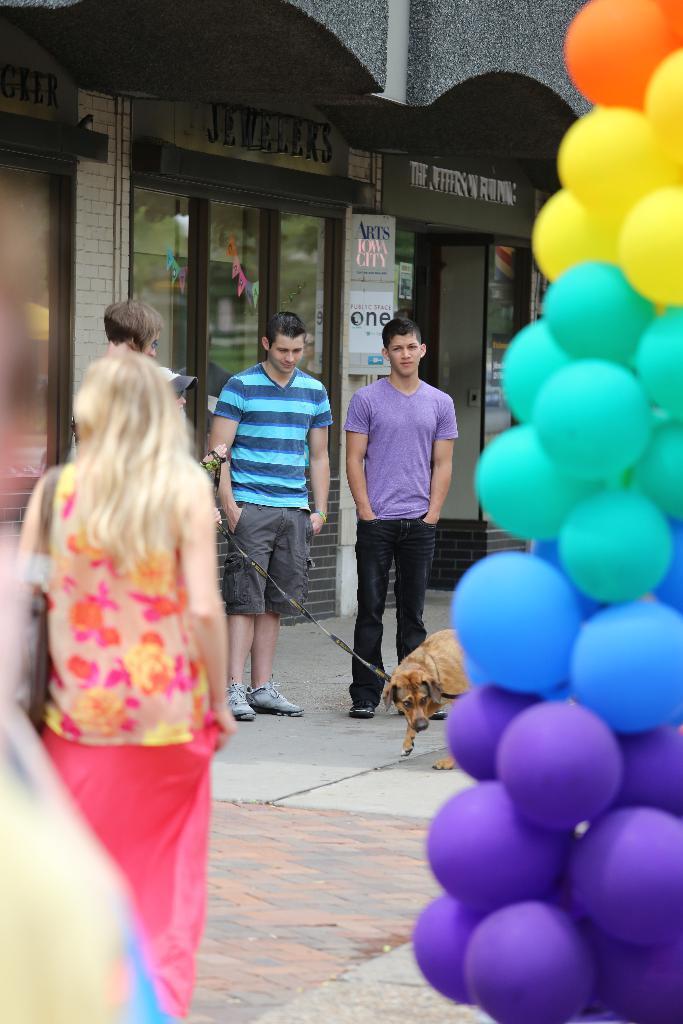Could you give a brief overview of what you see in this image? Here we can see a group of people standing on the road and on the right side we can see number of balloons present in the middle we can see a man holding a dog and behind him we can see a building 